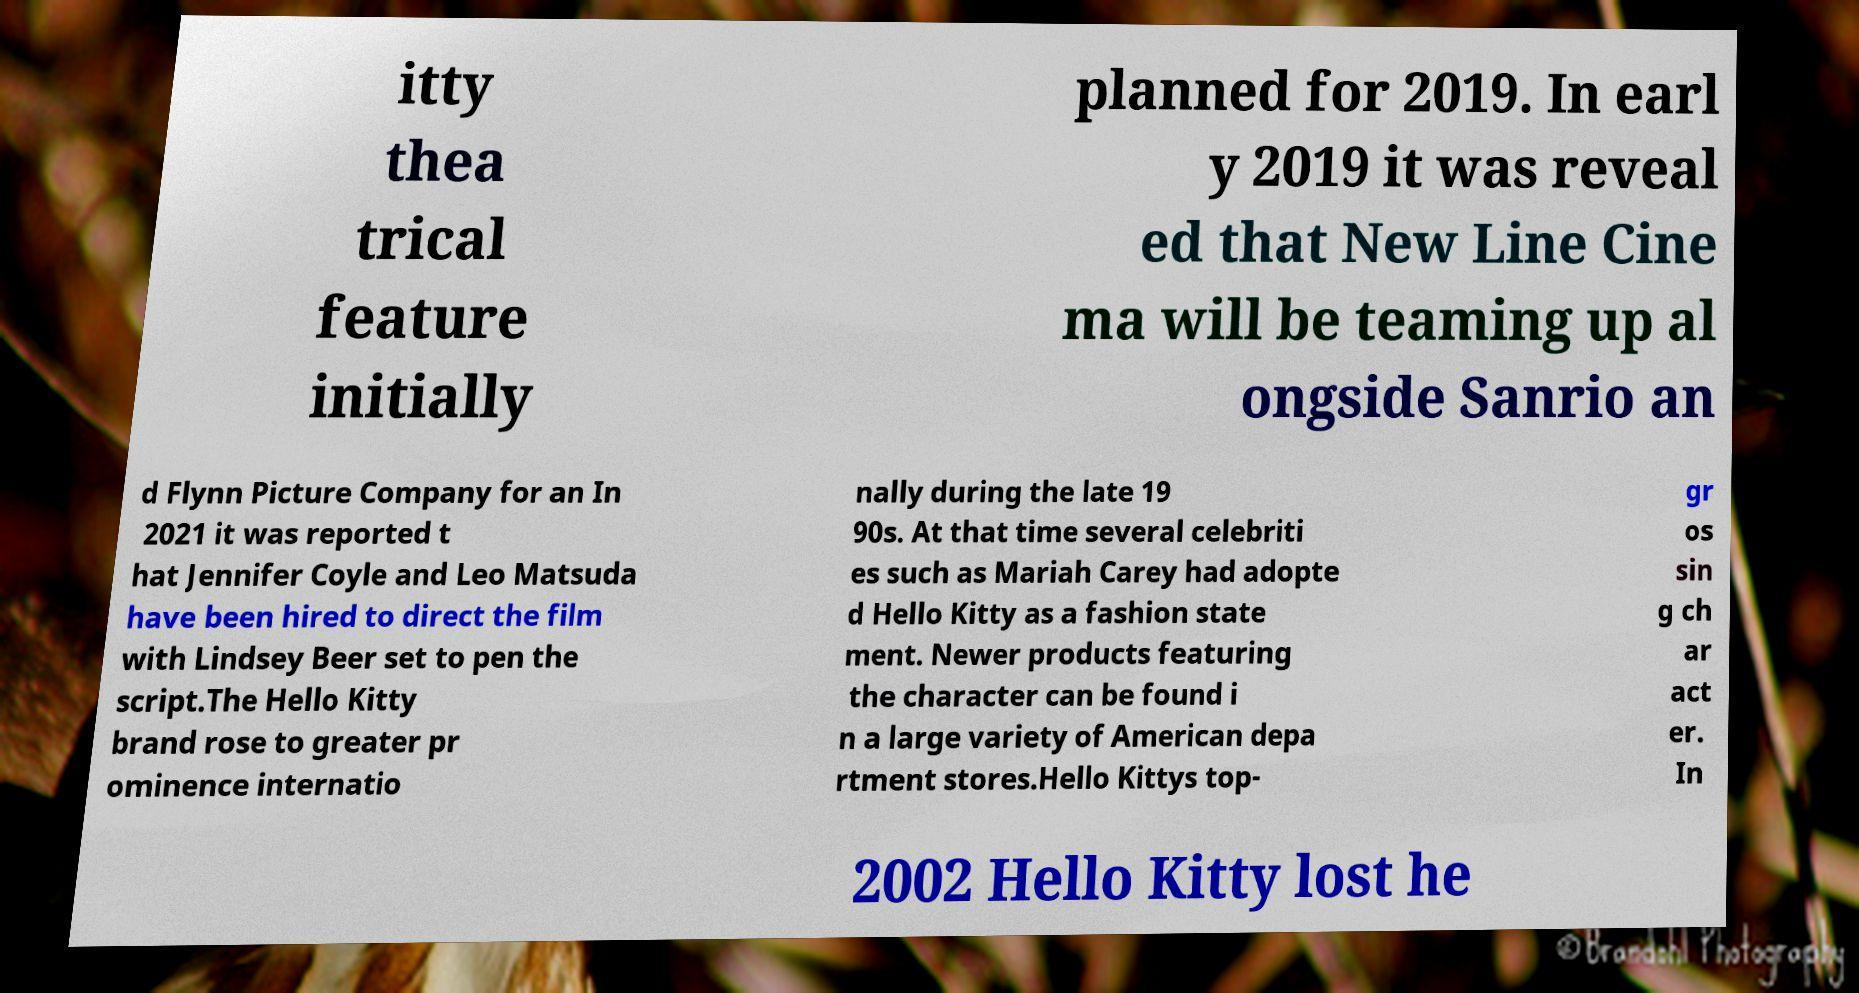Could you assist in decoding the text presented in this image and type it out clearly? itty thea trical feature initially planned for 2019. In earl y 2019 it was reveal ed that New Line Cine ma will be teaming up al ongside Sanrio an d Flynn Picture Company for an In 2021 it was reported t hat Jennifer Coyle and Leo Matsuda have been hired to direct the film with Lindsey Beer set to pen the script.The Hello Kitty brand rose to greater pr ominence internatio nally during the late 19 90s. At that time several celebriti es such as Mariah Carey had adopte d Hello Kitty as a fashion state ment. Newer products featuring the character can be found i n a large variety of American depa rtment stores.Hello Kittys top- gr os sin g ch ar act er. In 2002 Hello Kitty lost he 